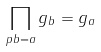Convert formula to latex. <formula><loc_0><loc_0><loc_500><loc_500>\prod _ { p b = a } g _ { b } = g _ { a }</formula> 